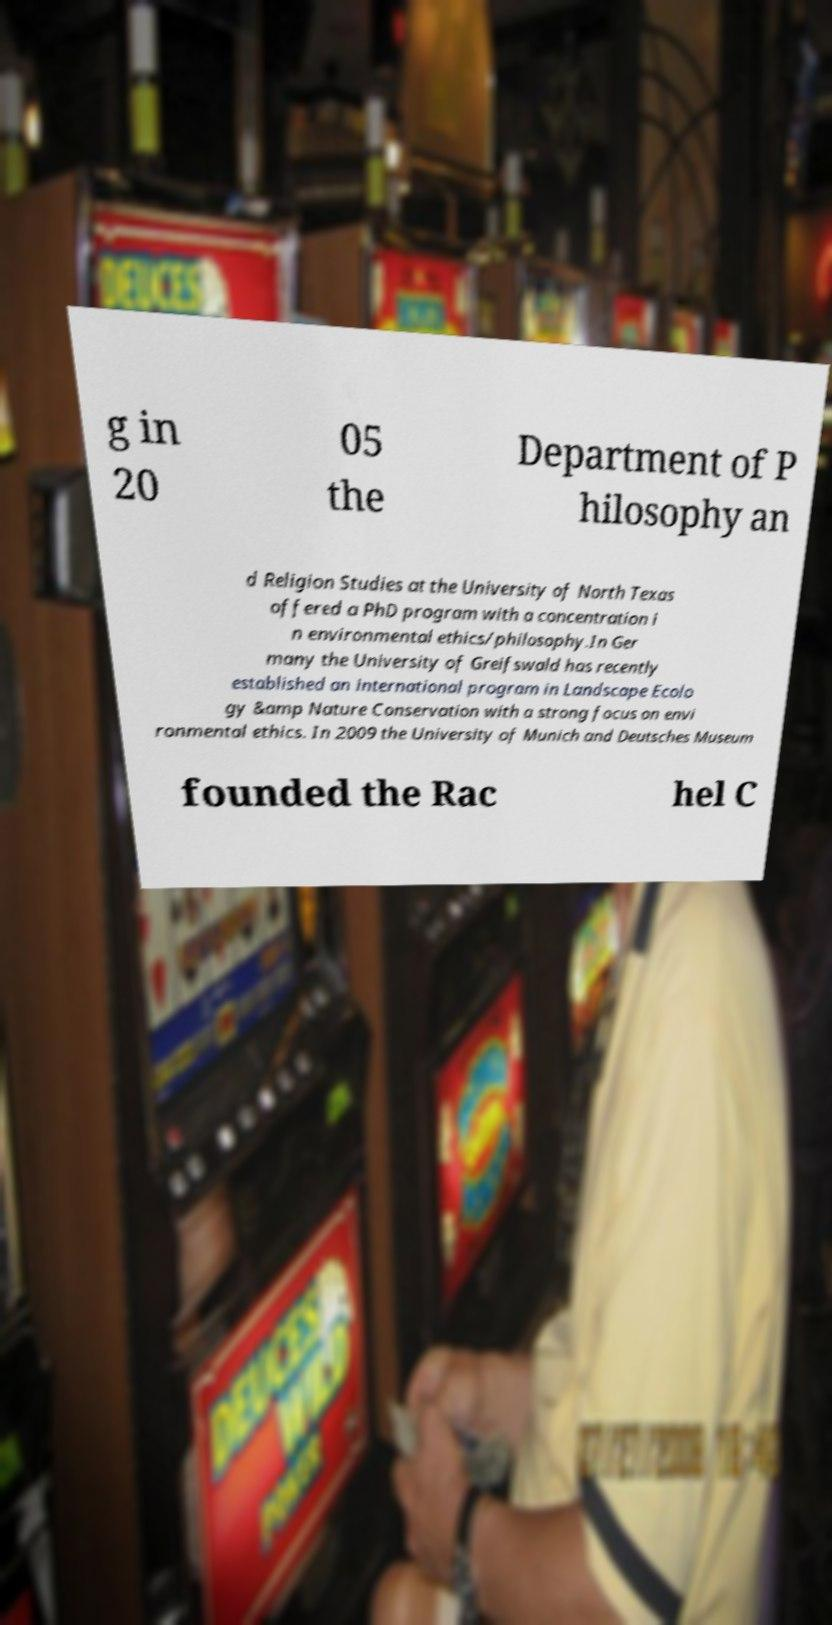Please identify and transcribe the text found in this image. g in 20 05 the Department of P hilosophy an d Religion Studies at the University of North Texas offered a PhD program with a concentration i n environmental ethics/philosophy.In Ger many the University of Greifswald has recently established an international program in Landscape Ecolo gy &amp Nature Conservation with a strong focus on envi ronmental ethics. In 2009 the University of Munich and Deutsches Museum founded the Rac hel C 